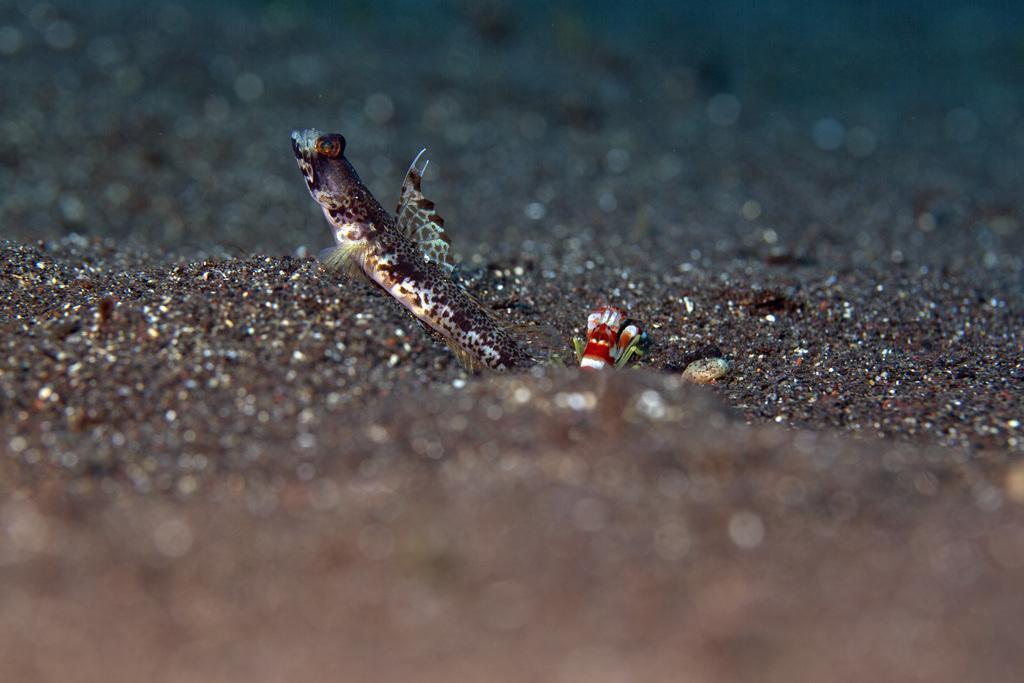What types of animals can be seen in the image? There are two different types of fish in the image. What type of terrain is visible in the image? Black soil is visible in the image. How would you describe the clarity of the image? The image is slightly blurry. What level of difficulty is the beginner's stretch depicted in the image? There is no stretch or any indication of difficulty level in the image; it features two types of fish and black soil. 